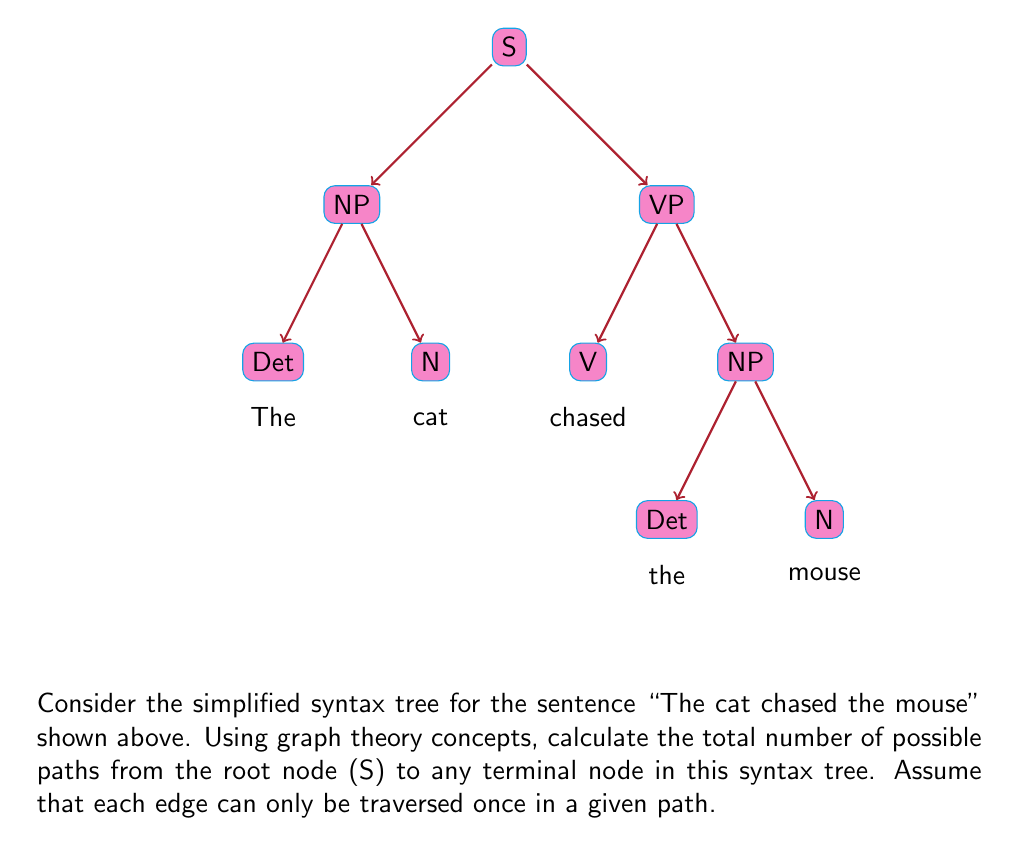Help me with this question. To solve this problem, we'll use the concept of path counting in a directed acyclic graph (DAG), which is what our syntax tree represents. We'll count the paths from the root to each terminal node and sum them up.

Let's break it down step-by-step:

1) First, identify the terminal nodes. In this syntax tree, we have 5 terminal nodes:
   - "The" (Det under the first NP)
   - "cat" (N under the first NP)
   - "chased" (V under VP)
   - "the" (Det under the second NP)
   - "mouse" (N under the second NP)

2) Now, let's count the paths to each terminal node:

   a) Path to "The": S → NP → Det
      Number of paths: 1

   b) Path to "cat": S → NP → N
      Number of paths: 1

   c) Path to "chased": S → VP → V
      Number of paths: 1

   d) Path to "the": S → VP → NP → Det
      Number of paths: 1

   e) Path to "mouse": S → VP → NP → N
      Number of paths: 1

3) The total number of paths is the sum of paths to all terminal nodes:
   
   $$ \text{Total paths} = 1 + 1 + 1 + 1 + 1 = 5 $$

This result can be verified by observing that each terminal node has exactly one unique path from the root node S, and there are 5 terminal nodes in total.

In graph theory terms, this tree has a "fan-out" structure where each non-terminal node branches out to distinct subtrees, resulting in unique paths to each terminal node.
Answer: 5 